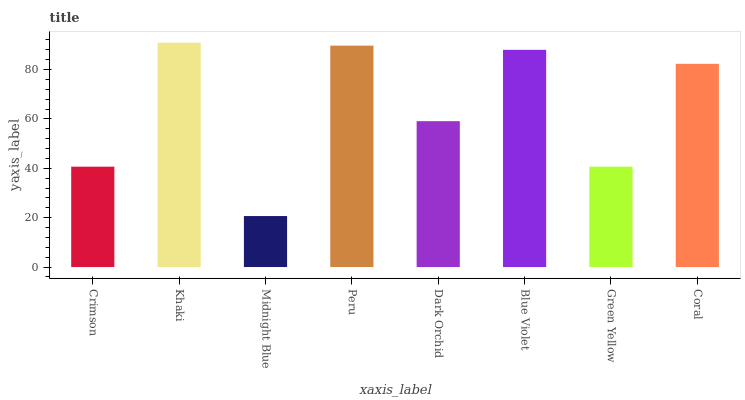Is Midnight Blue the minimum?
Answer yes or no. Yes. Is Khaki the maximum?
Answer yes or no. Yes. Is Khaki the minimum?
Answer yes or no. No. Is Midnight Blue the maximum?
Answer yes or no. No. Is Khaki greater than Midnight Blue?
Answer yes or no. Yes. Is Midnight Blue less than Khaki?
Answer yes or no. Yes. Is Midnight Blue greater than Khaki?
Answer yes or no. No. Is Khaki less than Midnight Blue?
Answer yes or no. No. Is Coral the high median?
Answer yes or no. Yes. Is Dark Orchid the low median?
Answer yes or no. Yes. Is Midnight Blue the high median?
Answer yes or no. No. Is Crimson the low median?
Answer yes or no. No. 